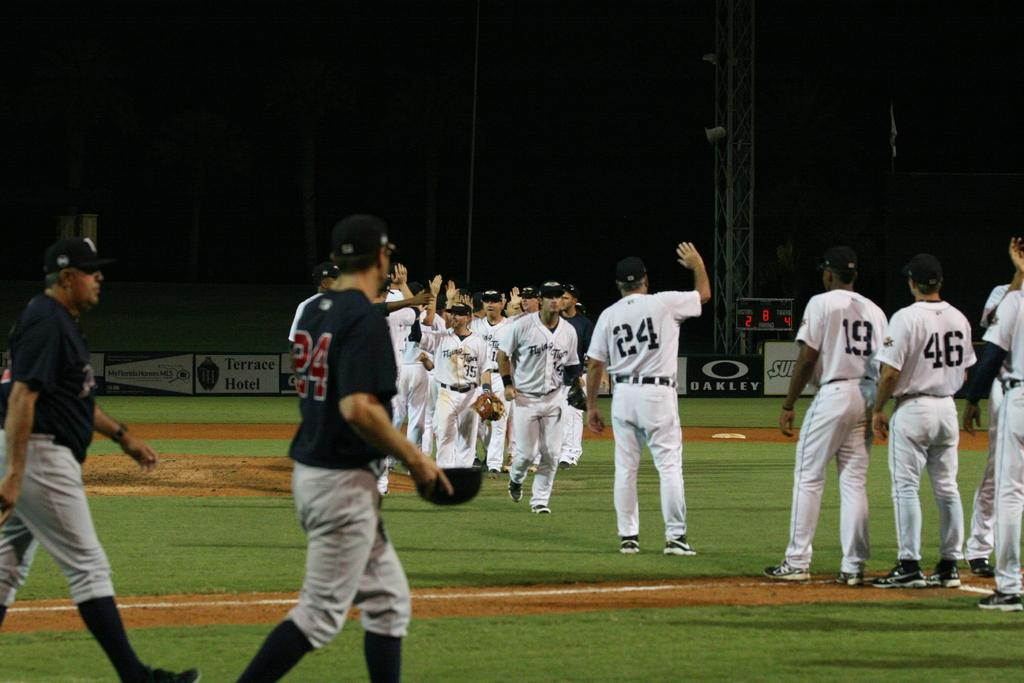<image>
Provide a brief description of the given image. Several baseball players are on the field, including one with the number "24" on his shirt. 